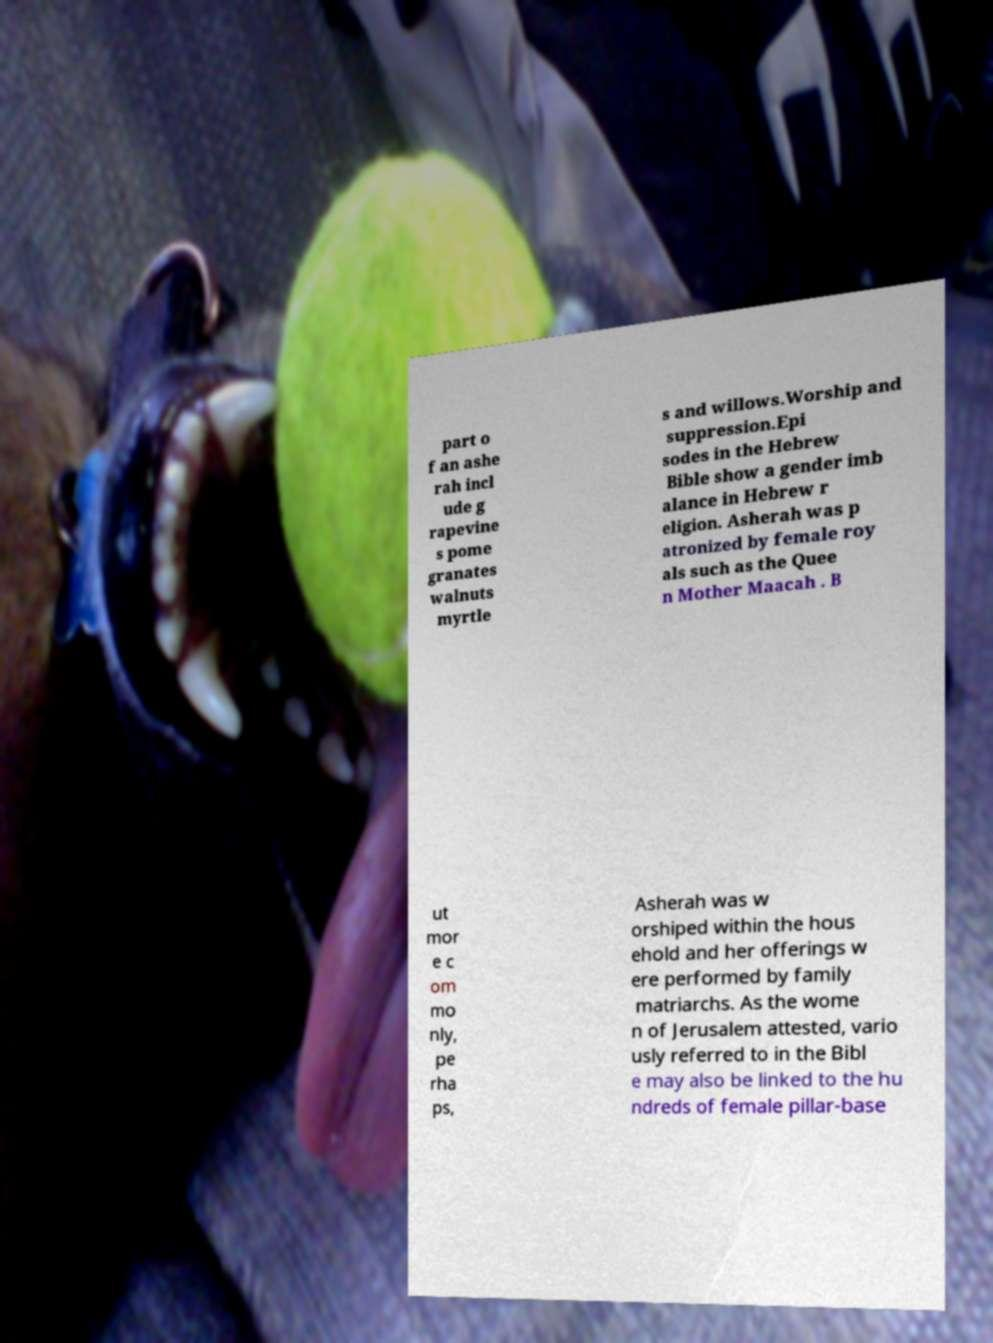Can you accurately transcribe the text from the provided image for me? part o f an ashe rah incl ude g rapevine s pome granates walnuts myrtle s and willows.Worship and suppression.Epi sodes in the Hebrew Bible show a gender imb alance in Hebrew r eligion. Asherah was p atronized by female roy als such as the Quee n Mother Maacah . B ut mor e c om mo nly, pe rha ps, Asherah was w orshiped within the hous ehold and her offerings w ere performed by family matriarchs. As the wome n of Jerusalem attested, vario usly referred to in the Bibl e may also be linked to the hu ndreds of female pillar-base 